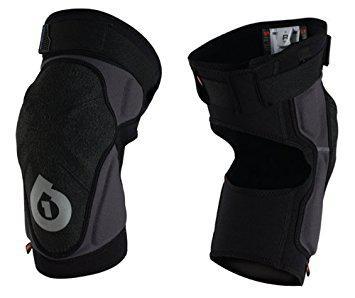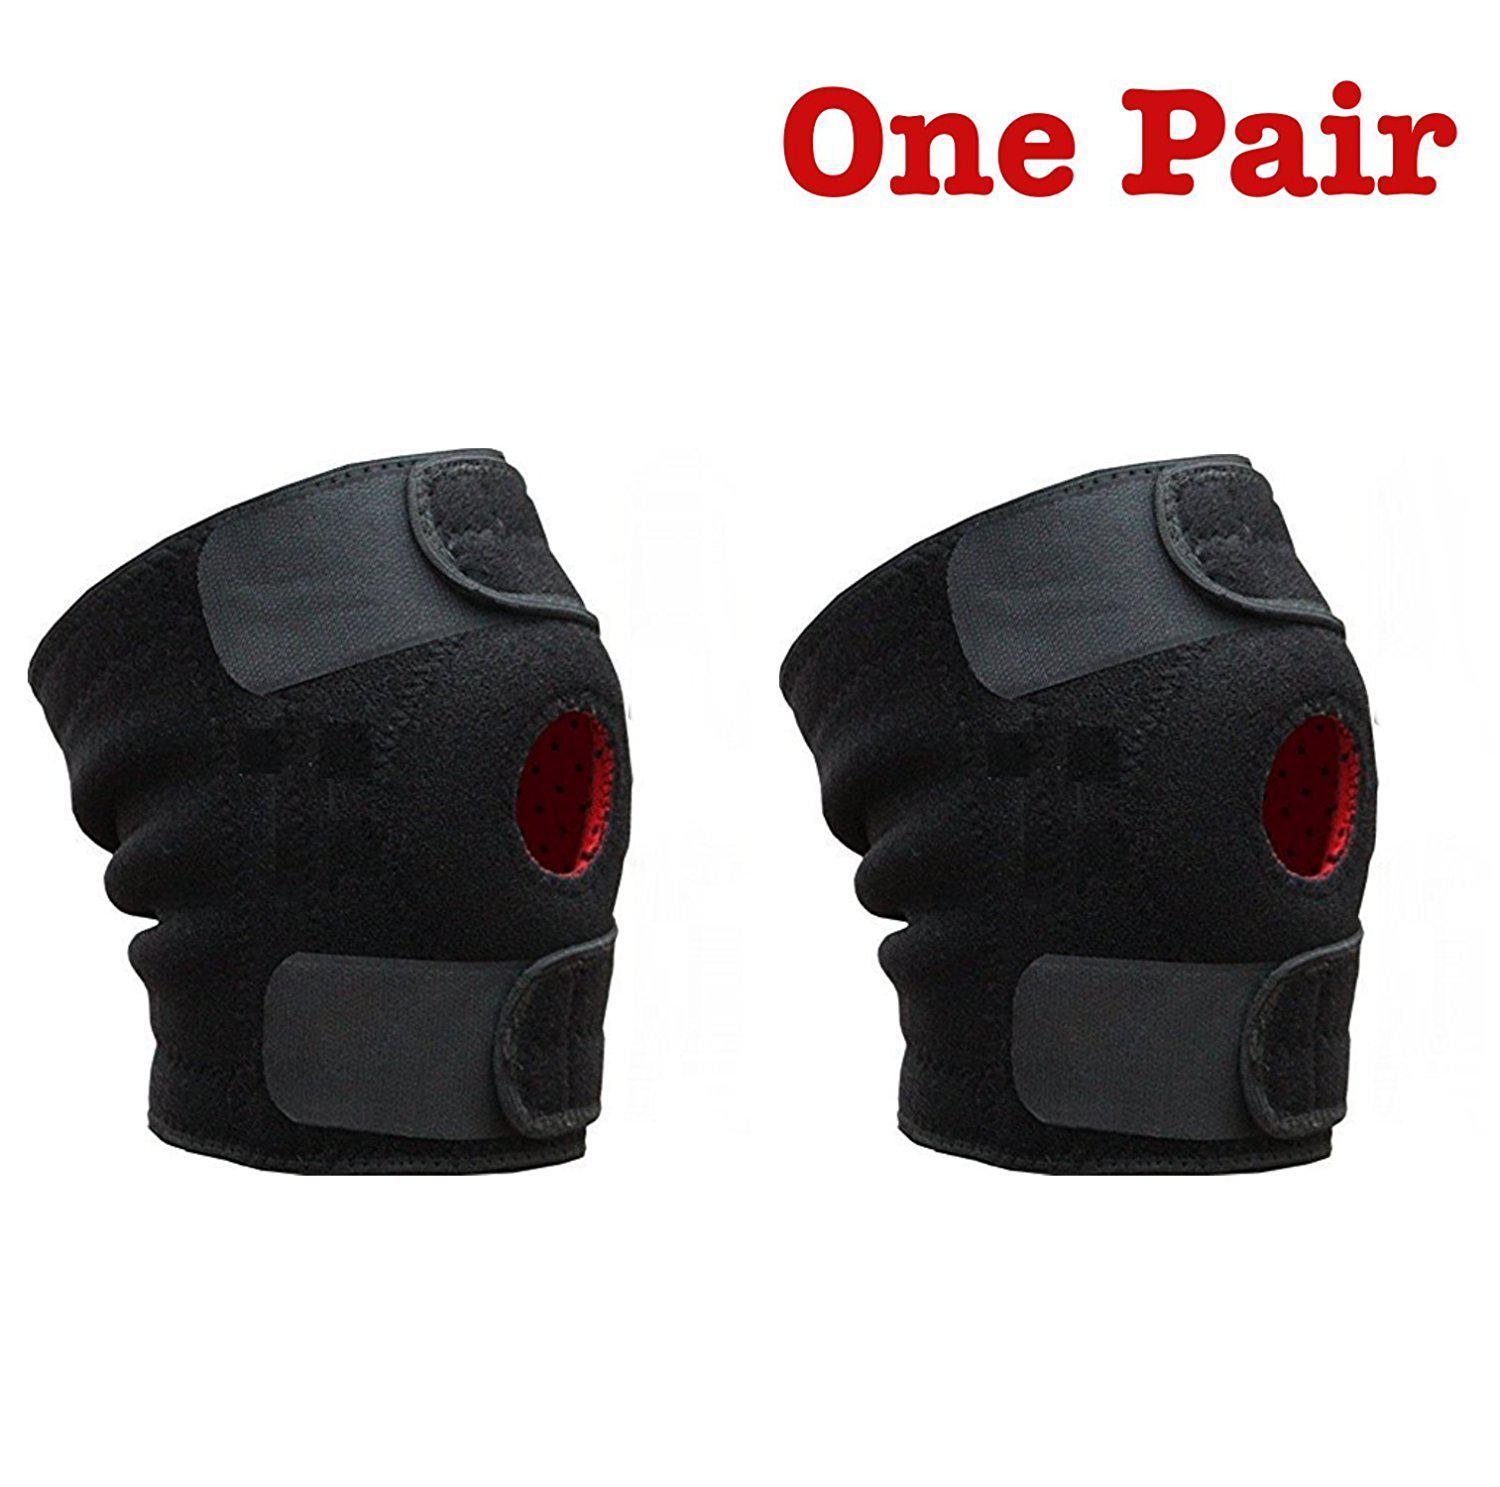The first image is the image on the left, the second image is the image on the right. Examine the images to the left and right. Is the description "At least one of the images has a human model wearing the item." accurate? Answer yes or no. No. The first image is the image on the left, the second image is the image on the right. Considering the images on both sides, is "One image shows someone wearing at least one of the knee pads." valid? Answer yes or no. No. 